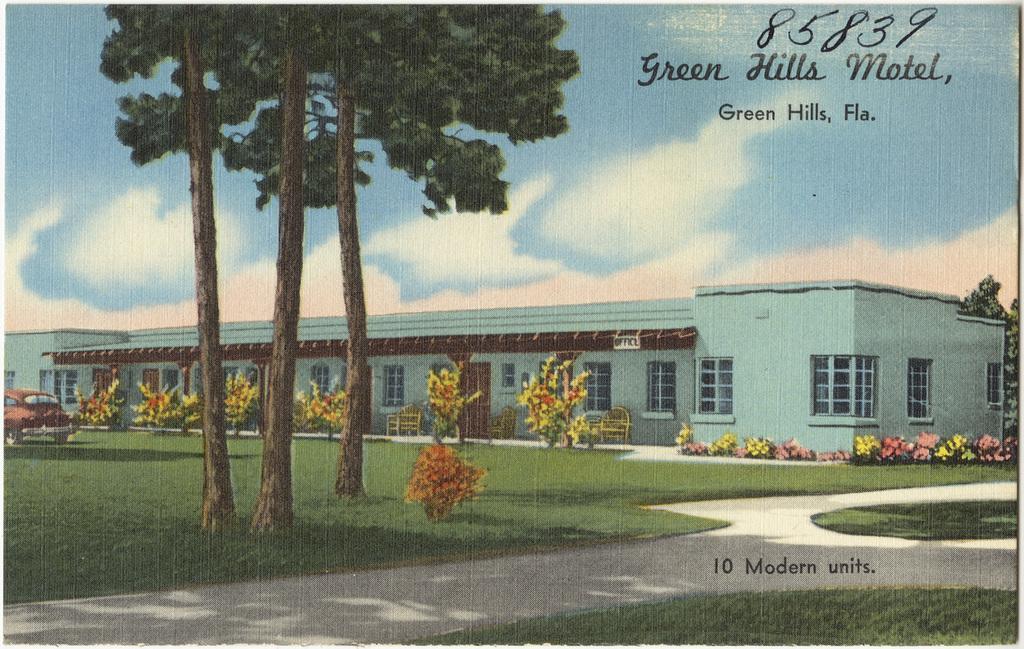Please provide a concise description of this image. This looks like a poster. This is the building with windows and doors. These are the chairs. I can see the letters in the image. This looks like a pathway. Here is the grass. I can see a car. These are the small bushes with colorful flowers. I can see the trees. 